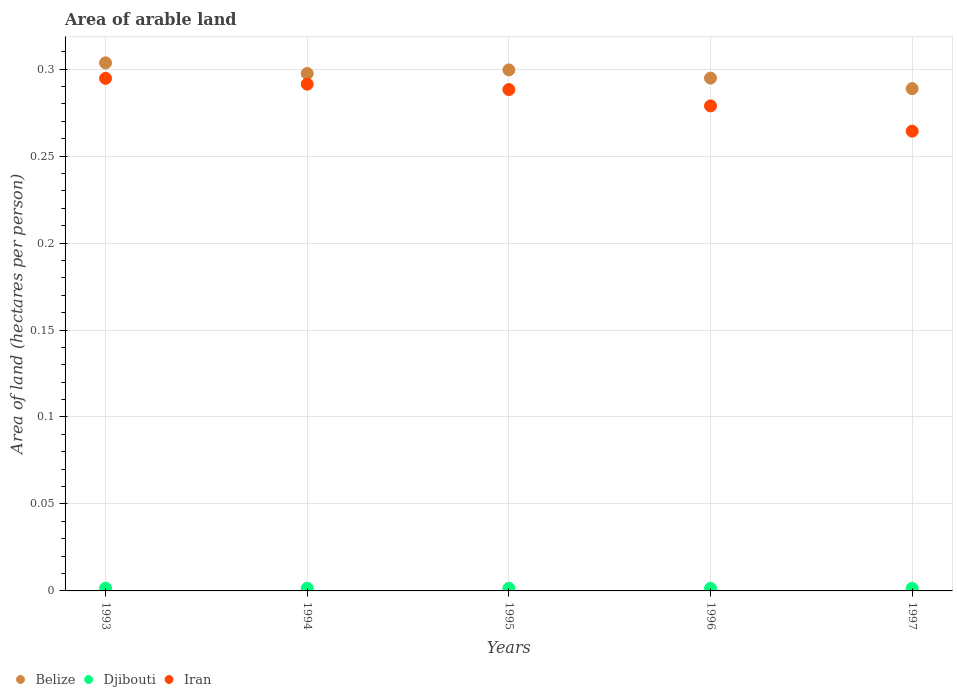How many different coloured dotlines are there?
Give a very brief answer. 3. Is the number of dotlines equal to the number of legend labels?
Make the answer very short. Yes. What is the total arable land in Iran in 1995?
Provide a succinct answer. 0.29. Across all years, what is the maximum total arable land in Belize?
Give a very brief answer. 0.3. Across all years, what is the minimum total arable land in Djibouti?
Provide a succinct answer. 0. In which year was the total arable land in Iran maximum?
Your answer should be compact. 1993. What is the total total arable land in Belize in the graph?
Offer a terse response. 1.48. What is the difference between the total arable land in Iran in 1994 and that in 1995?
Make the answer very short. 0. What is the difference between the total arable land in Belize in 1995 and the total arable land in Djibouti in 1996?
Provide a succinct answer. 0.3. What is the average total arable land in Belize per year?
Provide a short and direct response. 0.3. In the year 1993, what is the difference between the total arable land in Iran and total arable land in Belize?
Your answer should be compact. -0.01. What is the ratio of the total arable land in Iran in 1993 to that in 1995?
Offer a very short reply. 1.02. Is the total arable land in Djibouti in 1995 less than that in 1997?
Make the answer very short. No. Is the difference between the total arable land in Iran in 1993 and 1994 greater than the difference between the total arable land in Belize in 1993 and 1994?
Your answer should be very brief. No. What is the difference between the highest and the second highest total arable land in Djibouti?
Keep it short and to the point. 2.5668507439210184e-5. What is the difference between the highest and the lowest total arable land in Belize?
Give a very brief answer. 0.01. Is the sum of the total arable land in Iran in 1993 and 1997 greater than the maximum total arable land in Belize across all years?
Provide a short and direct response. Yes. Is it the case that in every year, the sum of the total arable land in Belize and total arable land in Iran  is greater than the total arable land in Djibouti?
Provide a succinct answer. Yes. Does the total arable land in Belize monotonically increase over the years?
Your answer should be compact. No. Is the total arable land in Belize strictly greater than the total arable land in Djibouti over the years?
Make the answer very short. Yes. Is the total arable land in Iran strictly less than the total arable land in Belize over the years?
Provide a succinct answer. Yes. How many years are there in the graph?
Your response must be concise. 5. What is the difference between two consecutive major ticks on the Y-axis?
Offer a terse response. 0.05. Are the values on the major ticks of Y-axis written in scientific E-notation?
Offer a terse response. No. Does the graph contain any zero values?
Your answer should be compact. No. Where does the legend appear in the graph?
Give a very brief answer. Bottom left. How many legend labels are there?
Ensure brevity in your answer.  3. What is the title of the graph?
Your answer should be very brief. Area of arable land. Does "Oman" appear as one of the legend labels in the graph?
Keep it short and to the point. No. What is the label or title of the Y-axis?
Provide a succinct answer. Area of land (hectares per person). What is the Area of land (hectares per person) in Belize in 1993?
Keep it short and to the point. 0.3. What is the Area of land (hectares per person) in Djibouti in 1993?
Your answer should be compact. 0. What is the Area of land (hectares per person) of Iran in 1993?
Offer a very short reply. 0.29. What is the Area of land (hectares per person) in Belize in 1994?
Keep it short and to the point. 0.3. What is the Area of land (hectares per person) of Djibouti in 1994?
Offer a very short reply. 0. What is the Area of land (hectares per person) of Iran in 1994?
Make the answer very short. 0.29. What is the Area of land (hectares per person) in Belize in 1995?
Provide a short and direct response. 0.3. What is the Area of land (hectares per person) of Djibouti in 1995?
Provide a short and direct response. 0. What is the Area of land (hectares per person) of Iran in 1995?
Keep it short and to the point. 0.29. What is the Area of land (hectares per person) of Belize in 1996?
Ensure brevity in your answer.  0.29. What is the Area of land (hectares per person) in Djibouti in 1996?
Give a very brief answer. 0. What is the Area of land (hectares per person) of Iran in 1996?
Offer a terse response. 0.28. What is the Area of land (hectares per person) in Belize in 1997?
Provide a succinct answer. 0.29. What is the Area of land (hectares per person) of Djibouti in 1997?
Your answer should be very brief. 0. What is the Area of land (hectares per person) of Iran in 1997?
Keep it short and to the point. 0.26. Across all years, what is the maximum Area of land (hectares per person) of Belize?
Provide a short and direct response. 0.3. Across all years, what is the maximum Area of land (hectares per person) of Djibouti?
Make the answer very short. 0. Across all years, what is the maximum Area of land (hectares per person) in Iran?
Provide a short and direct response. 0.29. Across all years, what is the minimum Area of land (hectares per person) of Belize?
Offer a terse response. 0.29. Across all years, what is the minimum Area of land (hectares per person) in Djibouti?
Offer a terse response. 0. Across all years, what is the minimum Area of land (hectares per person) of Iran?
Provide a succinct answer. 0.26. What is the total Area of land (hectares per person) in Belize in the graph?
Offer a terse response. 1.48. What is the total Area of land (hectares per person) of Djibouti in the graph?
Ensure brevity in your answer.  0.01. What is the total Area of land (hectares per person) in Iran in the graph?
Your response must be concise. 1.42. What is the difference between the Area of land (hectares per person) of Belize in 1993 and that in 1994?
Keep it short and to the point. 0.01. What is the difference between the Area of land (hectares per person) in Iran in 1993 and that in 1994?
Ensure brevity in your answer.  0. What is the difference between the Area of land (hectares per person) of Belize in 1993 and that in 1995?
Ensure brevity in your answer.  0. What is the difference between the Area of land (hectares per person) of Djibouti in 1993 and that in 1995?
Provide a short and direct response. 0. What is the difference between the Area of land (hectares per person) of Iran in 1993 and that in 1995?
Provide a succinct answer. 0.01. What is the difference between the Area of land (hectares per person) in Belize in 1993 and that in 1996?
Your answer should be very brief. 0.01. What is the difference between the Area of land (hectares per person) in Iran in 1993 and that in 1996?
Your response must be concise. 0.02. What is the difference between the Area of land (hectares per person) of Belize in 1993 and that in 1997?
Your answer should be compact. 0.01. What is the difference between the Area of land (hectares per person) in Djibouti in 1993 and that in 1997?
Offer a terse response. 0. What is the difference between the Area of land (hectares per person) in Iran in 1993 and that in 1997?
Give a very brief answer. 0.03. What is the difference between the Area of land (hectares per person) of Belize in 1994 and that in 1995?
Provide a succinct answer. -0. What is the difference between the Area of land (hectares per person) in Iran in 1994 and that in 1995?
Offer a terse response. 0. What is the difference between the Area of land (hectares per person) of Belize in 1994 and that in 1996?
Your answer should be compact. 0. What is the difference between the Area of land (hectares per person) of Djibouti in 1994 and that in 1996?
Provide a succinct answer. 0. What is the difference between the Area of land (hectares per person) of Iran in 1994 and that in 1996?
Offer a very short reply. 0.01. What is the difference between the Area of land (hectares per person) of Belize in 1994 and that in 1997?
Keep it short and to the point. 0.01. What is the difference between the Area of land (hectares per person) in Iran in 1994 and that in 1997?
Provide a short and direct response. 0.03. What is the difference between the Area of land (hectares per person) of Belize in 1995 and that in 1996?
Offer a terse response. 0. What is the difference between the Area of land (hectares per person) in Djibouti in 1995 and that in 1996?
Give a very brief answer. 0. What is the difference between the Area of land (hectares per person) of Iran in 1995 and that in 1996?
Give a very brief answer. 0.01. What is the difference between the Area of land (hectares per person) in Belize in 1995 and that in 1997?
Provide a succinct answer. 0.01. What is the difference between the Area of land (hectares per person) of Iran in 1995 and that in 1997?
Your response must be concise. 0.02. What is the difference between the Area of land (hectares per person) of Belize in 1996 and that in 1997?
Your answer should be compact. 0.01. What is the difference between the Area of land (hectares per person) in Djibouti in 1996 and that in 1997?
Give a very brief answer. 0. What is the difference between the Area of land (hectares per person) of Iran in 1996 and that in 1997?
Give a very brief answer. 0.01. What is the difference between the Area of land (hectares per person) of Belize in 1993 and the Area of land (hectares per person) of Djibouti in 1994?
Your response must be concise. 0.3. What is the difference between the Area of land (hectares per person) in Belize in 1993 and the Area of land (hectares per person) in Iran in 1994?
Your response must be concise. 0.01. What is the difference between the Area of land (hectares per person) of Djibouti in 1993 and the Area of land (hectares per person) of Iran in 1994?
Offer a terse response. -0.29. What is the difference between the Area of land (hectares per person) of Belize in 1993 and the Area of land (hectares per person) of Djibouti in 1995?
Provide a short and direct response. 0.3. What is the difference between the Area of land (hectares per person) in Belize in 1993 and the Area of land (hectares per person) in Iran in 1995?
Your response must be concise. 0.02. What is the difference between the Area of land (hectares per person) in Djibouti in 1993 and the Area of land (hectares per person) in Iran in 1995?
Your answer should be very brief. -0.29. What is the difference between the Area of land (hectares per person) of Belize in 1993 and the Area of land (hectares per person) of Djibouti in 1996?
Keep it short and to the point. 0.3. What is the difference between the Area of land (hectares per person) of Belize in 1993 and the Area of land (hectares per person) of Iran in 1996?
Provide a short and direct response. 0.02. What is the difference between the Area of land (hectares per person) in Djibouti in 1993 and the Area of land (hectares per person) in Iran in 1996?
Provide a short and direct response. -0.28. What is the difference between the Area of land (hectares per person) of Belize in 1993 and the Area of land (hectares per person) of Djibouti in 1997?
Ensure brevity in your answer.  0.3. What is the difference between the Area of land (hectares per person) in Belize in 1993 and the Area of land (hectares per person) in Iran in 1997?
Keep it short and to the point. 0.04. What is the difference between the Area of land (hectares per person) of Djibouti in 1993 and the Area of land (hectares per person) of Iran in 1997?
Provide a short and direct response. -0.26. What is the difference between the Area of land (hectares per person) of Belize in 1994 and the Area of land (hectares per person) of Djibouti in 1995?
Make the answer very short. 0.3. What is the difference between the Area of land (hectares per person) in Belize in 1994 and the Area of land (hectares per person) in Iran in 1995?
Provide a short and direct response. 0.01. What is the difference between the Area of land (hectares per person) in Djibouti in 1994 and the Area of land (hectares per person) in Iran in 1995?
Offer a terse response. -0.29. What is the difference between the Area of land (hectares per person) in Belize in 1994 and the Area of land (hectares per person) in Djibouti in 1996?
Offer a very short reply. 0.3. What is the difference between the Area of land (hectares per person) in Belize in 1994 and the Area of land (hectares per person) in Iran in 1996?
Your response must be concise. 0.02. What is the difference between the Area of land (hectares per person) of Djibouti in 1994 and the Area of land (hectares per person) of Iran in 1996?
Make the answer very short. -0.28. What is the difference between the Area of land (hectares per person) of Belize in 1994 and the Area of land (hectares per person) of Djibouti in 1997?
Provide a short and direct response. 0.3. What is the difference between the Area of land (hectares per person) of Belize in 1994 and the Area of land (hectares per person) of Iran in 1997?
Offer a terse response. 0.03. What is the difference between the Area of land (hectares per person) of Djibouti in 1994 and the Area of land (hectares per person) of Iran in 1997?
Make the answer very short. -0.26. What is the difference between the Area of land (hectares per person) of Belize in 1995 and the Area of land (hectares per person) of Djibouti in 1996?
Provide a succinct answer. 0.3. What is the difference between the Area of land (hectares per person) of Belize in 1995 and the Area of land (hectares per person) of Iran in 1996?
Offer a terse response. 0.02. What is the difference between the Area of land (hectares per person) in Djibouti in 1995 and the Area of land (hectares per person) in Iran in 1996?
Make the answer very short. -0.28. What is the difference between the Area of land (hectares per person) in Belize in 1995 and the Area of land (hectares per person) in Djibouti in 1997?
Your answer should be very brief. 0.3. What is the difference between the Area of land (hectares per person) in Belize in 1995 and the Area of land (hectares per person) in Iran in 1997?
Your answer should be very brief. 0.04. What is the difference between the Area of land (hectares per person) of Djibouti in 1995 and the Area of land (hectares per person) of Iran in 1997?
Make the answer very short. -0.26. What is the difference between the Area of land (hectares per person) in Belize in 1996 and the Area of land (hectares per person) in Djibouti in 1997?
Make the answer very short. 0.29. What is the difference between the Area of land (hectares per person) in Belize in 1996 and the Area of land (hectares per person) in Iran in 1997?
Give a very brief answer. 0.03. What is the difference between the Area of land (hectares per person) in Djibouti in 1996 and the Area of land (hectares per person) in Iran in 1997?
Offer a terse response. -0.26. What is the average Area of land (hectares per person) in Belize per year?
Keep it short and to the point. 0.3. What is the average Area of land (hectares per person) of Djibouti per year?
Provide a succinct answer. 0. What is the average Area of land (hectares per person) in Iran per year?
Provide a short and direct response. 0.28. In the year 1993, what is the difference between the Area of land (hectares per person) of Belize and Area of land (hectares per person) of Djibouti?
Provide a succinct answer. 0.3. In the year 1993, what is the difference between the Area of land (hectares per person) in Belize and Area of land (hectares per person) in Iran?
Your answer should be very brief. 0.01. In the year 1993, what is the difference between the Area of land (hectares per person) in Djibouti and Area of land (hectares per person) in Iran?
Provide a succinct answer. -0.29. In the year 1994, what is the difference between the Area of land (hectares per person) in Belize and Area of land (hectares per person) in Djibouti?
Give a very brief answer. 0.3. In the year 1994, what is the difference between the Area of land (hectares per person) of Belize and Area of land (hectares per person) of Iran?
Provide a short and direct response. 0.01. In the year 1994, what is the difference between the Area of land (hectares per person) of Djibouti and Area of land (hectares per person) of Iran?
Give a very brief answer. -0.29. In the year 1995, what is the difference between the Area of land (hectares per person) of Belize and Area of land (hectares per person) of Djibouti?
Provide a short and direct response. 0.3. In the year 1995, what is the difference between the Area of land (hectares per person) of Belize and Area of land (hectares per person) of Iran?
Give a very brief answer. 0.01. In the year 1995, what is the difference between the Area of land (hectares per person) of Djibouti and Area of land (hectares per person) of Iran?
Your answer should be compact. -0.29. In the year 1996, what is the difference between the Area of land (hectares per person) of Belize and Area of land (hectares per person) of Djibouti?
Your answer should be compact. 0.29. In the year 1996, what is the difference between the Area of land (hectares per person) of Belize and Area of land (hectares per person) of Iran?
Give a very brief answer. 0.02. In the year 1996, what is the difference between the Area of land (hectares per person) of Djibouti and Area of land (hectares per person) of Iran?
Your response must be concise. -0.28. In the year 1997, what is the difference between the Area of land (hectares per person) of Belize and Area of land (hectares per person) of Djibouti?
Keep it short and to the point. 0.29. In the year 1997, what is the difference between the Area of land (hectares per person) in Belize and Area of land (hectares per person) in Iran?
Offer a terse response. 0.02. In the year 1997, what is the difference between the Area of land (hectares per person) of Djibouti and Area of land (hectares per person) of Iran?
Make the answer very short. -0.26. What is the ratio of the Area of land (hectares per person) in Belize in 1993 to that in 1994?
Your answer should be very brief. 1.02. What is the ratio of the Area of land (hectares per person) of Djibouti in 1993 to that in 1994?
Ensure brevity in your answer.  1.02. What is the ratio of the Area of land (hectares per person) in Iran in 1993 to that in 1994?
Your answer should be very brief. 1.01. What is the ratio of the Area of land (hectares per person) in Belize in 1993 to that in 1995?
Keep it short and to the point. 1.01. What is the ratio of the Area of land (hectares per person) in Djibouti in 1993 to that in 1995?
Provide a succinct answer. 1.03. What is the ratio of the Area of land (hectares per person) of Iran in 1993 to that in 1995?
Your answer should be very brief. 1.02. What is the ratio of the Area of land (hectares per person) in Belize in 1993 to that in 1996?
Offer a very short reply. 1.03. What is the ratio of the Area of land (hectares per person) in Djibouti in 1993 to that in 1996?
Provide a short and direct response. 1.05. What is the ratio of the Area of land (hectares per person) in Iran in 1993 to that in 1996?
Your answer should be compact. 1.06. What is the ratio of the Area of land (hectares per person) of Belize in 1993 to that in 1997?
Make the answer very short. 1.05. What is the ratio of the Area of land (hectares per person) in Djibouti in 1993 to that in 1997?
Your response must be concise. 1.07. What is the ratio of the Area of land (hectares per person) of Iran in 1993 to that in 1997?
Your response must be concise. 1.11. What is the ratio of the Area of land (hectares per person) in Djibouti in 1994 to that in 1995?
Provide a short and direct response. 1.02. What is the ratio of the Area of land (hectares per person) of Iran in 1994 to that in 1995?
Make the answer very short. 1.01. What is the ratio of the Area of land (hectares per person) of Djibouti in 1994 to that in 1996?
Your answer should be very brief. 1.04. What is the ratio of the Area of land (hectares per person) in Iran in 1994 to that in 1996?
Keep it short and to the point. 1.04. What is the ratio of the Area of land (hectares per person) of Belize in 1994 to that in 1997?
Ensure brevity in your answer.  1.03. What is the ratio of the Area of land (hectares per person) in Djibouti in 1994 to that in 1997?
Make the answer very short. 1.05. What is the ratio of the Area of land (hectares per person) in Iran in 1994 to that in 1997?
Offer a terse response. 1.1. What is the ratio of the Area of land (hectares per person) in Djibouti in 1995 to that in 1996?
Keep it short and to the point. 1.02. What is the ratio of the Area of land (hectares per person) of Iran in 1995 to that in 1996?
Your answer should be compact. 1.03. What is the ratio of the Area of land (hectares per person) in Belize in 1995 to that in 1997?
Make the answer very short. 1.04. What is the ratio of the Area of land (hectares per person) of Djibouti in 1995 to that in 1997?
Make the answer very short. 1.04. What is the ratio of the Area of land (hectares per person) of Iran in 1995 to that in 1997?
Offer a terse response. 1.09. What is the ratio of the Area of land (hectares per person) of Belize in 1996 to that in 1997?
Your response must be concise. 1.02. What is the ratio of the Area of land (hectares per person) in Djibouti in 1996 to that in 1997?
Offer a very short reply. 1.02. What is the ratio of the Area of land (hectares per person) of Iran in 1996 to that in 1997?
Your answer should be very brief. 1.05. What is the difference between the highest and the second highest Area of land (hectares per person) in Belize?
Keep it short and to the point. 0. What is the difference between the highest and the second highest Area of land (hectares per person) of Djibouti?
Provide a short and direct response. 0. What is the difference between the highest and the second highest Area of land (hectares per person) of Iran?
Offer a very short reply. 0. What is the difference between the highest and the lowest Area of land (hectares per person) in Belize?
Provide a short and direct response. 0.01. What is the difference between the highest and the lowest Area of land (hectares per person) in Iran?
Offer a terse response. 0.03. 